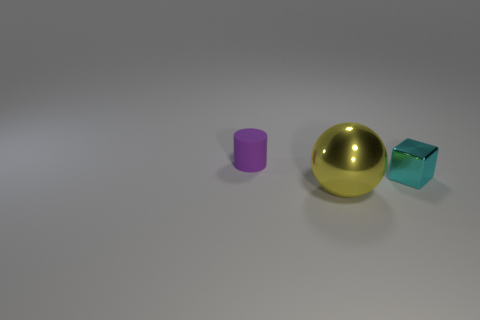Is the material of the object that is right of the large yellow sphere the same as the thing in front of the small cyan metallic thing?
Keep it short and to the point. Yes. Are there any other things that have the same size as the sphere?
Your answer should be compact. No. Is the number of yellow things behind the large sphere less than the number of cyan blocks that are in front of the purple object?
Your answer should be very brief. Yes. What number of other objects are there of the same shape as the small matte thing?
Ensure brevity in your answer.  0. The cyan thing that is the same material as the large yellow thing is what shape?
Your answer should be compact. Cube. There is a thing that is left of the cyan metal block and in front of the purple rubber object; what is its color?
Your response must be concise. Yellow. Are the small thing that is right of the tiny purple rubber cylinder and the ball made of the same material?
Ensure brevity in your answer.  Yes. Is the number of purple matte cylinders that are right of the big yellow shiny ball less than the number of purple cylinders?
Your answer should be very brief. Yes. Are there any small cubes made of the same material as the yellow thing?
Your answer should be compact. Yes. There is a cyan block; is it the same size as the purple object to the left of the cyan metallic object?
Keep it short and to the point. Yes. 